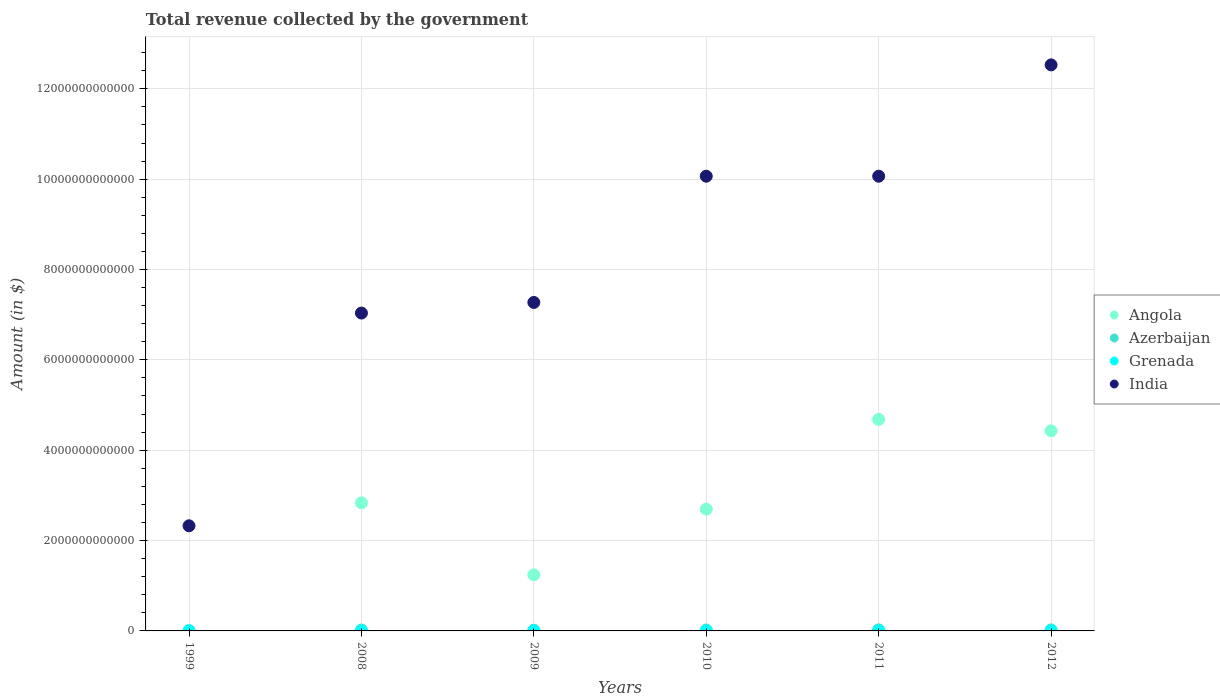Is the number of dotlines equal to the number of legend labels?
Provide a succinct answer. Yes. What is the total revenue collected by the government in Grenada in 2010?
Provide a short and direct response. 4.15e+08. Across all years, what is the maximum total revenue collected by the government in India?
Provide a short and direct response. 1.25e+13. Across all years, what is the minimum total revenue collected by the government in Angola?
Give a very brief answer. 7.21e+09. In which year was the total revenue collected by the government in Angola minimum?
Keep it short and to the point. 1999. What is the total total revenue collected by the government in India in the graph?
Your answer should be very brief. 4.93e+13. What is the difference between the total revenue collected by the government in Angola in 1999 and that in 2009?
Your response must be concise. -1.23e+12. What is the difference between the total revenue collected by the government in Grenada in 2011 and the total revenue collected by the government in India in 2010?
Offer a very short reply. -1.01e+13. What is the average total revenue collected by the government in Grenada per year?
Ensure brevity in your answer.  4.00e+08. In the year 2011, what is the difference between the total revenue collected by the government in Azerbaijan and total revenue collected by the government in Angola?
Your response must be concise. -4.66e+12. What is the ratio of the total revenue collected by the government in India in 2009 to that in 2011?
Your response must be concise. 0.72. Is the total revenue collected by the government in Angola in 1999 less than that in 2010?
Provide a succinct answer. Yes. Is the difference between the total revenue collected by the government in Azerbaijan in 2008 and 2010 greater than the difference between the total revenue collected by the government in Angola in 2008 and 2010?
Your response must be concise. No. What is the difference between the highest and the second highest total revenue collected by the government in Azerbaijan?
Offer a terse response. 1.09e+09. What is the difference between the highest and the lowest total revenue collected by the government in Azerbaijan?
Your answer should be very brief. 2.30e+1. In how many years, is the total revenue collected by the government in India greater than the average total revenue collected by the government in India taken over all years?
Provide a short and direct response. 3. Is the sum of the total revenue collected by the government in Azerbaijan in 1999 and 2012 greater than the maximum total revenue collected by the government in India across all years?
Offer a very short reply. No. Is it the case that in every year, the sum of the total revenue collected by the government in Grenada and total revenue collected by the government in Angola  is greater than the sum of total revenue collected by the government in India and total revenue collected by the government in Azerbaijan?
Your answer should be very brief. No. How many dotlines are there?
Make the answer very short. 4. How many years are there in the graph?
Offer a terse response. 6. What is the difference between two consecutive major ticks on the Y-axis?
Ensure brevity in your answer.  2.00e+12. Does the graph contain grids?
Provide a short and direct response. Yes. Where does the legend appear in the graph?
Your answer should be very brief. Center right. What is the title of the graph?
Your answer should be very brief. Total revenue collected by the government. What is the label or title of the Y-axis?
Make the answer very short. Amount (in $). What is the Amount (in $) in Angola in 1999?
Offer a terse response. 7.21e+09. What is the Amount (in $) in Azerbaijan in 1999?
Offer a terse response. 6.63e+08. What is the Amount (in $) of Grenada in 1999?
Make the answer very short. 2.67e+08. What is the Amount (in $) in India in 1999?
Your answer should be compact. 2.33e+12. What is the Amount (in $) of Angola in 2008?
Keep it short and to the point. 2.83e+12. What is the Amount (in $) in Azerbaijan in 2008?
Give a very brief answer. 1.98e+1. What is the Amount (in $) in Grenada in 2008?
Your answer should be very brief. 4.65e+08. What is the Amount (in $) of India in 2008?
Make the answer very short. 7.04e+12. What is the Amount (in $) of Angola in 2009?
Provide a succinct answer. 1.24e+12. What is the Amount (in $) of Azerbaijan in 2009?
Your response must be concise. 1.46e+1. What is the Amount (in $) in Grenada in 2009?
Give a very brief answer. 4.02e+08. What is the Amount (in $) of India in 2009?
Provide a succinct answer. 7.27e+12. What is the Amount (in $) in Angola in 2010?
Offer a very short reply. 2.70e+12. What is the Amount (in $) in Azerbaijan in 2010?
Keep it short and to the point. 1.99e+1. What is the Amount (in $) of Grenada in 2010?
Your answer should be compact. 4.15e+08. What is the Amount (in $) in India in 2010?
Offer a terse response. 1.01e+13. What is the Amount (in $) in Angola in 2011?
Your response must be concise. 4.68e+12. What is the Amount (in $) in Azerbaijan in 2011?
Keep it short and to the point. 2.37e+1. What is the Amount (in $) of Grenada in 2011?
Ensure brevity in your answer.  4.26e+08. What is the Amount (in $) of India in 2011?
Provide a short and direct response. 1.01e+13. What is the Amount (in $) in Angola in 2012?
Make the answer very short. 4.43e+12. What is the Amount (in $) of Azerbaijan in 2012?
Your response must be concise. 2.26e+1. What is the Amount (in $) of Grenada in 2012?
Provide a succinct answer. 4.25e+08. What is the Amount (in $) of India in 2012?
Keep it short and to the point. 1.25e+13. Across all years, what is the maximum Amount (in $) of Angola?
Your response must be concise. 4.68e+12. Across all years, what is the maximum Amount (in $) in Azerbaijan?
Ensure brevity in your answer.  2.37e+1. Across all years, what is the maximum Amount (in $) of Grenada?
Your response must be concise. 4.65e+08. Across all years, what is the maximum Amount (in $) of India?
Offer a terse response. 1.25e+13. Across all years, what is the minimum Amount (in $) in Angola?
Your answer should be very brief. 7.21e+09. Across all years, what is the minimum Amount (in $) of Azerbaijan?
Your answer should be compact. 6.63e+08. Across all years, what is the minimum Amount (in $) in Grenada?
Your response must be concise. 2.67e+08. Across all years, what is the minimum Amount (in $) in India?
Make the answer very short. 2.33e+12. What is the total Amount (in $) of Angola in the graph?
Give a very brief answer. 1.59e+13. What is the total Amount (in $) in Azerbaijan in the graph?
Your answer should be compact. 1.01e+11. What is the total Amount (in $) of Grenada in the graph?
Give a very brief answer. 2.40e+09. What is the total Amount (in $) of India in the graph?
Give a very brief answer. 4.93e+13. What is the difference between the Amount (in $) of Angola in 1999 and that in 2008?
Your answer should be very brief. -2.83e+12. What is the difference between the Amount (in $) in Azerbaijan in 1999 and that in 2008?
Provide a succinct answer. -1.91e+1. What is the difference between the Amount (in $) of Grenada in 1999 and that in 2008?
Make the answer very short. -1.97e+08. What is the difference between the Amount (in $) in India in 1999 and that in 2008?
Your answer should be compact. -4.71e+12. What is the difference between the Amount (in $) of Angola in 1999 and that in 2009?
Keep it short and to the point. -1.23e+12. What is the difference between the Amount (in $) in Azerbaijan in 1999 and that in 2009?
Give a very brief answer. -1.39e+1. What is the difference between the Amount (in $) in Grenada in 1999 and that in 2009?
Offer a very short reply. -1.34e+08. What is the difference between the Amount (in $) in India in 1999 and that in 2009?
Make the answer very short. -4.94e+12. What is the difference between the Amount (in $) in Angola in 1999 and that in 2010?
Your answer should be very brief. -2.69e+12. What is the difference between the Amount (in $) in Azerbaijan in 1999 and that in 2010?
Offer a terse response. -1.92e+1. What is the difference between the Amount (in $) in Grenada in 1999 and that in 2010?
Offer a very short reply. -1.48e+08. What is the difference between the Amount (in $) of India in 1999 and that in 2010?
Provide a succinct answer. -7.74e+12. What is the difference between the Amount (in $) in Angola in 1999 and that in 2011?
Offer a terse response. -4.68e+12. What is the difference between the Amount (in $) in Azerbaijan in 1999 and that in 2011?
Offer a terse response. -2.30e+1. What is the difference between the Amount (in $) of Grenada in 1999 and that in 2011?
Provide a short and direct response. -1.58e+08. What is the difference between the Amount (in $) of India in 1999 and that in 2011?
Offer a very short reply. -7.74e+12. What is the difference between the Amount (in $) of Angola in 1999 and that in 2012?
Ensure brevity in your answer.  -4.42e+12. What is the difference between the Amount (in $) of Azerbaijan in 1999 and that in 2012?
Give a very brief answer. -2.19e+1. What is the difference between the Amount (in $) in Grenada in 1999 and that in 2012?
Your response must be concise. -1.58e+08. What is the difference between the Amount (in $) in India in 1999 and that in 2012?
Your answer should be compact. -1.02e+13. What is the difference between the Amount (in $) of Angola in 2008 and that in 2009?
Offer a terse response. 1.59e+12. What is the difference between the Amount (in $) of Azerbaijan in 2008 and that in 2009?
Provide a short and direct response. 5.23e+09. What is the difference between the Amount (in $) in Grenada in 2008 and that in 2009?
Your answer should be compact. 6.28e+07. What is the difference between the Amount (in $) in India in 2008 and that in 2009?
Keep it short and to the point. -2.35e+11. What is the difference between the Amount (in $) of Angola in 2008 and that in 2010?
Offer a terse response. 1.39e+11. What is the difference between the Amount (in $) in Azerbaijan in 2008 and that in 2010?
Your answer should be very brief. -9.75e+07. What is the difference between the Amount (in $) of Grenada in 2008 and that in 2010?
Give a very brief answer. 4.96e+07. What is the difference between the Amount (in $) in India in 2008 and that in 2010?
Your answer should be very brief. -3.03e+12. What is the difference between the Amount (in $) in Angola in 2008 and that in 2011?
Your answer should be compact. -1.85e+12. What is the difference between the Amount (in $) of Azerbaijan in 2008 and that in 2011?
Provide a succinct answer. -3.90e+09. What is the difference between the Amount (in $) in Grenada in 2008 and that in 2011?
Your answer should be compact. 3.89e+07. What is the difference between the Amount (in $) in India in 2008 and that in 2011?
Provide a short and direct response. -3.03e+12. What is the difference between the Amount (in $) of Angola in 2008 and that in 2012?
Ensure brevity in your answer.  -1.59e+12. What is the difference between the Amount (in $) of Azerbaijan in 2008 and that in 2012?
Offer a very short reply. -2.81e+09. What is the difference between the Amount (in $) in Grenada in 2008 and that in 2012?
Provide a succinct answer. 3.93e+07. What is the difference between the Amount (in $) in India in 2008 and that in 2012?
Provide a short and direct response. -5.49e+12. What is the difference between the Amount (in $) of Angola in 2009 and that in 2010?
Offer a terse response. -1.45e+12. What is the difference between the Amount (in $) of Azerbaijan in 2009 and that in 2010?
Your answer should be very brief. -5.33e+09. What is the difference between the Amount (in $) of Grenada in 2009 and that in 2010?
Provide a succinct answer. -1.32e+07. What is the difference between the Amount (in $) of India in 2009 and that in 2010?
Ensure brevity in your answer.  -2.79e+12. What is the difference between the Amount (in $) of Angola in 2009 and that in 2011?
Give a very brief answer. -3.44e+12. What is the difference between the Amount (in $) of Azerbaijan in 2009 and that in 2011?
Your answer should be compact. -9.13e+09. What is the difference between the Amount (in $) in Grenada in 2009 and that in 2011?
Make the answer very short. -2.39e+07. What is the difference between the Amount (in $) of India in 2009 and that in 2011?
Give a very brief answer. -2.79e+12. What is the difference between the Amount (in $) in Angola in 2009 and that in 2012?
Make the answer very short. -3.19e+12. What is the difference between the Amount (in $) of Azerbaijan in 2009 and that in 2012?
Provide a short and direct response. -8.04e+09. What is the difference between the Amount (in $) of Grenada in 2009 and that in 2012?
Offer a very short reply. -2.35e+07. What is the difference between the Amount (in $) of India in 2009 and that in 2012?
Keep it short and to the point. -5.26e+12. What is the difference between the Amount (in $) of Angola in 2010 and that in 2011?
Ensure brevity in your answer.  -1.99e+12. What is the difference between the Amount (in $) in Azerbaijan in 2010 and that in 2011?
Offer a terse response. -3.80e+09. What is the difference between the Amount (in $) in Grenada in 2010 and that in 2011?
Ensure brevity in your answer.  -1.07e+07. What is the difference between the Amount (in $) in India in 2010 and that in 2011?
Your response must be concise. 0. What is the difference between the Amount (in $) of Angola in 2010 and that in 2012?
Give a very brief answer. -1.73e+12. What is the difference between the Amount (in $) of Azerbaijan in 2010 and that in 2012?
Your answer should be compact. -2.71e+09. What is the difference between the Amount (in $) in Grenada in 2010 and that in 2012?
Make the answer very short. -1.03e+07. What is the difference between the Amount (in $) of India in 2010 and that in 2012?
Ensure brevity in your answer.  -2.46e+12. What is the difference between the Amount (in $) of Angola in 2011 and that in 2012?
Provide a succinct answer. 2.54e+11. What is the difference between the Amount (in $) of Azerbaijan in 2011 and that in 2012?
Provide a succinct answer. 1.09e+09. What is the difference between the Amount (in $) of Grenada in 2011 and that in 2012?
Ensure brevity in your answer.  4.00e+05. What is the difference between the Amount (in $) of India in 2011 and that in 2012?
Offer a terse response. -2.46e+12. What is the difference between the Amount (in $) of Angola in 1999 and the Amount (in $) of Azerbaijan in 2008?
Offer a terse response. -1.26e+1. What is the difference between the Amount (in $) in Angola in 1999 and the Amount (in $) in Grenada in 2008?
Provide a short and direct response. 6.75e+09. What is the difference between the Amount (in $) in Angola in 1999 and the Amount (in $) in India in 2008?
Give a very brief answer. -7.03e+12. What is the difference between the Amount (in $) in Azerbaijan in 1999 and the Amount (in $) in Grenada in 2008?
Ensure brevity in your answer.  1.99e+08. What is the difference between the Amount (in $) of Azerbaijan in 1999 and the Amount (in $) of India in 2008?
Offer a very short reply. -7.04e+12. What is the difference between the Amount (in $) in Grenada in 1999 and the Amount (in $) in India in 2008?
Offer a very short reply. -7.04e+12. What is the difference between the Amount (in $) of Angola in 1999 and the Amount (in $) of Azerbaijan in 2009?
Make the answer very short. -7.34e+09. What is the difference between the Amount (in $) in Angola in 1999 and the Amount (in $) in Grenada in 2009?
Your answer should be compact. 6.81e+09. What is the difference between the Amount (in $) in Angola in 1999 and the Amount (in $) in India in 2009?
Keep it short and to the point. -7.26e+12. What is the difference between the Amount (in $) in Azerbaijan in 1999 and the Amount (in $) in Grenada in 2009?
Your response must be concise. 2.62e+08. What is the difference between the Amount (in $) in Azerbaijan in 1999 and the Amount (in $) in India in 2009?
Offer a terse response. -7.27e+12. What is the difference between the Amount (in $) in Grenada in 1999 and the Amount (in $) in India in 2009?
Your answer should be compact. -7.27e+12. What is the difference between the Amount (in $) of Angola in 1999 and the Amount (in $) of Azerbaijan in 2010?
Provide a short and direct response. -1.27e+1. What is the difference between the Amount (in $) in Angola in 1999 and the Amount (in $) in Grenada in 2010?
Offer a very short reply. 6.80e+09. What is the difference between the Amount (in $) of Angola in 1999 and the Amount (in $) of India in 2010?
Offer a terse response. -1.01e+13. What is the difference between the Amount (in $) of Azerbaijan in 1999 and the Amount (in $) of Grenada in 2010?
Offer a terse response. 2.48e+08. What is the difference between the Amount (in $) of Azerbaijan in 1999 and the Amount (in $) of India in 2010?
Your answer should be compact. -1.01e+13. What is the difference between the Amount (in $) in Grenada in 1999 and the Amount (in $) in India in 2010?
Your response must be concise. -1.01e+13. What is the difference between the Amount (in $) in Angola in 1999 and the Amount (in $) in Azerbaijan in 2011?
Give a very brief answer. -1.65e+1. What is the difference between the Amount (in $) of Angola in 1999 and the Amount (in $) of Grenada in 2011?
Offer a terse response. 6.79e+09. What is the difference between the Amount (in $) of Angola in 1999 and the Amount (in $) of India in 2011?
Your answer should be very brief. -1.01e+13. What is the difference between the Amount (in $) of Azerbaijan in 1999 and the Amount (in $) of Grenada in 2011?
Provide a short and direct response. 2.38e+08. What is the difference between the Amount (in $) in Azerbaijan in 1999 and the Amount (in $) in India in 2011?
Provide a succinct answer. -1.01e+13. What is the difference between the Amount (in $) of Grenada in 1999 and the Amount (in $) of India in 2011?
Provide a succinct answer. -1.01e+13. What is the difference between the Amount (in $) of Angola in 1999 and the Amount (in $) of Azerbaijan in 2012?
Your answer should be very brief. -1.54e+1. What is the difference between the Amount (in $) of Angola in 1999 and the Amount (in $) of Grenada in 2012?
Give a very brief answer. 6.79e+09. What is the difference between the Amount (in $) in Angola in 1999 and the Amount (in $) in India in 2012?
Your answer should be very brief. -1.25e+13. What is the difference between the Amount (in $) of Azerbaijan in 1999 and the Amount (in $) of Grenada in 2012?
Ensure brevity in your answer.  2.38e+08. What is the difference between the Amount (in $) in Azerbaijan in 1999 and the Amount (in $) in India in 2012?
Keep it short and to the point. -1.25e+13. What is the difference between the Amount (in $) in Grenada in 1999 and the Amount (in $) in India in 2012?
Your response must be concise. -1.25e+13. What is the difference between the Amount (in $) in Angola in 2008 and the Amount (in $) in Azerbaijan in 2009?
Your answer should be compact. 2.82e+12. What is the difference between the Amount (in $) of Angola in 2008 and the Amount (in $) of Grenada in 2009?
Give a very brief answer. 2.83e+12. What is the difference between the Amount (in $) of Angola in 2008 and the Amount (in $) of India in 2009?
Keep it short and to the point. -4.44e+12. What is the difference between the Amount (in $) in Azerbaijan in 2008 and the Amount (in $) in Grenada in 2009?
Your response must be concise. 1.94e+1. What is the difference between the Amount (in $) in Azerbaijan in 2008 and the Amount (in $) in India in 2009?
Your answer should be very brief. -7.25e+12. What is the difference between the Amount (in $) in Grenada in 2008 and the Amount (in $) in India in 2009?
Make the answer very short. -7.27e+12. What is the difference between the Amount (in $) in Angola in 2008 and the Amount (in $) in Azerbaijan in 2010?
Offer a terse response. 2.81e+12. What is the difference between the Amount (in $) in Angola in 2008 and the Amount (in $) in Grenada in 2010?
Ensure brevity in your answer.  2.83e+12. What is the difference between the Amount (in $) of Angola in 2008 and the Amount (in $) of India in 2010?
Give a very brief answer. -7.23e+12. What is the difference between the Amount (in $) of Azerbaijan in 2008 and the Amount (in $) of Grenada in 2010?
Provide a succinct answer. 1.94e+1. What is the difference between the Amount (in $) of Azerbaijan in 2008 and the Amount (in $) of India in 2010?
Offer a terse response. -1.00e+13. What is the difference between the Amount (in $) in Grenada in 2008 and the Amount (in $) in India in 2010?
Your response must be concise. -1.01e+13. What is the difference between the Amount (in $) in Angola in 2008 and the Amount (in $) in Azerbaijan in 2011?
Your answer should be compact. 2.81e+12. What is the difference between the Amount (in $) in Angola in 2008 and the Amount (in $) in Grenada in 2011?
Provide a succinct answer. 2.83e+12. What is the difference between the Amount (in $) of Angola in 2008 and the Amount (in $) of India in 2011?
Offer a terse response. -7.23e+12. What is the difference between the Amount (in $) of Azerbaijan in 2008 and the Amount (in $) of Grenada in 2011?
Make the answer very short. 1.94e+1. What is the difference between the Amount (in $) in Azerbaijan in 2008 and the Amount (in $) in India in 2011?
Ensure brevity in your answer.  -1.00e+13. What is the difference between the Amount (in $) in Grenada in 2008 and the Amount (in $) in India in 2011?
Make the answer very short. -1.01e+13. What is the difference between the Amount (in $) of Angola in 2008 and the Amount (in $) of Azerbaijan in 2012?
Keep it short and to the point. 2.81e+12. What is the difference between the Amount (in $) of Angola in 2008 and the Amount (in $) of Grenada in 2012?
Your response must be concise. 2.83e+12. What is the difference between the Amount (in $) of Angola in 2008 and the Amount (in $) of India in 2012?
Ensure brevity in your answer.  -9.69e+12. What is the difference between the Amount (in $) of Azerbaijan in 2008 and the Amount (in $) of Grenada in 2012?
Make the answer very short. 1.94e+1. What is the difference between the Amount (in $) of Azerbaijan in 2008 and the Amount (in $) of India in 2012?
Offer a terse response. -1.25e+13. What is the difference between the Amount (in $) of Grenada in 2008 and the Amount (in $) of India in 2012?
Ensure brevity in your answer.  -1.25e+13. What is the difference between the Amount (in $) in Angola in 2009 and the Amount (in $) in Azerbaijan in 2010?
Your response must be concise. 1.22e+12. What is the difference between the Amount (in $) of Angola in 2009 and the Amount (in $) of Grenada in 2010?
Provide a short and direct response. 1.24e+12. What is the difference between the Amount (in $) of Angola in 2009 and the Amount (in $) of India in 2010?
Make the answer very short. -8.82e+12. What is the difference between the Amount (in $) in Azerbaijan in 2009 and the Amount (in $) in Grenada in 2010?
Your answer should be very brief. 1.41e+1. What is the difference between the Amount (in $) of Azerbaijan in 2009 and the Amount (in $) of India in 2010?
Provide a succinct answer. -1.01e+13. What is the difference between the Amount (in $) in Grenada in 2009 and the Amount (in $) in India in 2010?
Provide a short and direct response. -1.01e+13. What is the difference between the Amount (in $) of Angola in 2009 and the Amount (in $) of Azerbaijan in 2011?
Offer a terse response. 1.22e+12. What is the difference between the Amount (in $) in Angola in 2009 and the Amount (in $) in Grenada in 2011?
Offer a terse response. 1.24e+12. What is the difference between the Amount (in $) in Angola in 2009 and the Amount (in $) in India in 2011?
Ensure brevity in your answer.  -8.82e+12. What is the difference between the Amount (in $) of Azerbaijan in 2009 and the Amount (in $) of Grenada in 2011?
Ensure brevity in your answer.  1.41e+1. What is the difference between the Amount (in $) in Azerbaijan in 2009 and the Amount (in $) in India in 2011?
Provide a short and direct response. -1.01e+13. What is the difference between the Amount (in $) in Grenada in 2009 and the Amount (in $) in India in 2011?
Keep it short and to the point. -1.01e+13. What is the difference between the Amount (in $) in Angola in 2009 and the Amount (in $) in Azerbaijan in 2012?
Make the answer very short. 1.22e+12. What is the difference between the Amount (in $) in Angola in 2009 and the Amount (in $) in Grenada in 2012?
Offer a very short reply. 1.24e+12. What is the difference between the Amount (in $) of Angola in 2009 and the Amount (in $) of India in 2012?
Give a very brief answer. -1.13e+13. What is the difference between the Amount (in $) in Azerbaijan in 2009 and the Amount (in $) in Grenada in 2012?
Provide a succinct answer. 1.41e+1. What is the difference between the Amount (in $) in Azerbaijan in 2009 and the Amount (in $) in India in 2012?
Make the answer very short. -1.25e+13. What is the difference between the Amount (in $) of Grenada in 2009 and the Amount (in $) of India in 2012?
Your answer should be compact. -1.25e+13. What is the difference between the Amount (in $) in Angola in 2010 and the Amount (in $) in Azerbaijan in 2011?
Provide a succinct answer. 2.67e+12. What is the difference between the Amount (in $) of Angola in 2010 and the Amount (in $) of Grenada in 2011?
Provide a short and direct response. 2.69e+12. What is the difference between the Amount (in $) in Angola in 2010 and the Amount (in $) in India in 2011?
Provide a short and direct response. -7.37e+12. What is the difference between the Amount (in $) in Azerbaijan in 2010 and the Amount (in $) in Grenada in 2011?
Make the answer very short. 1.95e+1. What is the difference between the Amount (in $) of Azerbaijan in 2010 and the Amount (in $) of India in 2011?
Keep it short and to the point. -1.00e+13. What is the difference between the Amount (in $) of Grenada in 2010 and the Amount (in $) of India in 2011?
Ensure brevity in your answer.  -1.01e+13. What is the difference between the Amount (in $) of Angola in 2010 and the Amount (in $) of Azerbaijan in 2012?
Offer a very short reply. 2.67e+12. What is the difference between the Amount (in $) in Angola in 2010 and the Amount (in $) in Grenada in 2012?
Give a very brief answer. 2.69e+12. What is the difference between the Amount (in $) in Angola in 2010 and the Amount (in $) in India in 2012?
Offer a very short reply. -9.83e+12. What is the difference between the Amount (in $) of Azerbaijan in 2010 and the Amount (in $) of Grenada in 2012?
Your answer should be compact. 1.95e+1. What is the difference between the Amount (in $) of Azerbaijan in 2010 and the Amount (in $) of India in 2012?
Provide a short and direct response. -1.25e+13. What is the difference between the Amount (in $) of Grenada in 2010 and the Amount (in $) of India in 2012?
Ensure brevity in your answer.  -1.25e+13. What is the difference between the Amount (in $) in Angola in 2011 and the Amount (in $) in Azerbaijan in 2012?
Provide a short and direct response. 4.66e+12. What is the difference between the Amount (in $) in Angola in 2011 and the Amount (in $) in Grenada in 2012?
Your answer should be very brief. 4.68e+12. What is the difference between the Amount (in $) in Angola in 2011 and the Amount (in $) in India in 2012?
Provide a short and direct response. -7.85e+12. What is the difference between the Amount (in $) of Azerbaijan in 2011 and the Amount (in $) of Grenada in 2012?
Make the answer very short. 2.33e+1. What is the difference between the Amount (in $) of Azerbaijan in 2011 and the Amount (in $) of India in 2012?
Offer a very short reply. -1.25e+13. What is the difference between the Amount (in $) of Grenada in 2011 and the Amount (in $) of India in 2012?
Your response must be concise. -1.25e+13. What is the average Amount (in $) in Angola per year?
Your response must be concise. 2.65e+12. What is the average Amount (in $) of Azerbaijan per year?
Your answer should be very brief. 1.69e+1. What is the average Amount (in $) in Grenada per year?
Make the answer very short. 4.00e+08. What is the average Amount (in $) of India per year?
Provide a succinct answer. 8.22e+12. In the year 1999, what is the difference between the Amount (in $) in Angola and Amount (in $) in Azerbaijan?
Make the answer very short. 6.55e+09. In the year 1999, what is the difference between the Amount (in $) in Angola and Amount (in $) in Grenada?
Give a very brief answer. 6.95e+09. In the year 1999, what is the difference between the Amount (in $) of Angola and Amount (in $) of India?
Offer a very short reply. -2.32e+12. In the year 1999, what is the difference between the Amount (in $) in Azerbaijan and Amount (in $) in Grenada?
Offer a very short reply. 3.96e+08. In the year 1999, what is the difference between the Amount (in $) in Azerbaijan and Amount (in $) in India?
Your response must be concise. -2.33e+12. In the year 1999, what is the difference between the Amount (in $) of Grenada and Amount (in $) of India?
Provide a succinct answer. -2.33e+12. In the year 2008, what is the difference between the Amount (in $) of Angola and Amount (in $) of Azerbaijan?
Your answer should be compact. 2.81e+12. In the year 2008, what is the difference between the Amount (in $) in Angola and Amount (in $) in Grenada?
Give a very brief answer. 2.83e+12. In the year 2008, what is the difference between the Amount (in $) of Angola and Amount (in $) of India?
Keep it short and to the point. -4.20e+12. In the year 2008, what is the difference between the Amount (in $) in Azerbaijan and Amount (in $) in Grenada?
Give a very brief answer. 1.93e+1. In the year 2008, what is the difference between the Amount (in $) in Azerbaijan and Amount (in $) in India?
Provide a short and direct response. -7.02e+12. In the year 2008, what is the difference between the Amount (in $) of Grenada and Amount (in $) of India?
Ensure brevity in your answer.  -7.04e+12. In the year 2009, what is the difference between the Amount (in $) in Angola and Amount (in $) in Azerbaijan?
Offer a terse response. 1.23e+12. In the year 2009, what is the difference between the Amount (in $) of Angola and Amount (in $) of Grenada?
Offer a very short reply. 1.24e+12. In the year 2009, what is the difference between the Amount (in $) of Angola and Amount (in $) of India?
Your answer should be very brief. -6.03e+12. In the year 2009, what is the difference between the Amount (in $) in Azerbaijan and Amount (in $) in Grenada?
Provide a succinct answer. 1.42e+1. In the year 2009, what is the difference between the Amount (in $) of Azerbaijan and Amount (in $) of India?
Keep it short and to the point. -7.26e+12. In the year 2009, what is the difference between the Amount (in $) in Grenada and Amount (in $) in India?
Offer a very short reply. -7.27e+12. In the year 2010, what is the difference between the Amount (in $) in Angola and Amount (in $) in Azerbaijan?
Your answer should be very brief. 2.68e+12. In the year 2010, what is the difference between the Amount (in $) of Angola and Amount (in $) of Grenada?
Keep it short and to the point. 2.69e+12. In the year 2010, what is the difference between the Amount (in $) of Angola and Amount (in $) of India?
Offer a terse response. -7.37e+12. In the year 2010, what is the difference between the Amount (in $) of Azerbaijan and Amount (in $) of Grenada?
Offer a very short reply. 1.95e+1. In the year 2010, what is the difference between the Amount (in $) of Azerbaijan and Amount (in $) of India?
Give a very brief answer. -1.00e+13. In the year 2010, what is the difference between the Amount (in $) of Grenada and Amount (in $) of India?
Ensure brevity in your answer.  -1.01e+13. In the year 2011, what is the difference between the Amount (in $) in Angola and Amount (in $) in Azerbaijan?
Provide a short and direct response. 4.66e+12. In the year 2011, what is the difference between the Amount (in $) of Angola and Amount (in $) of Grenada?
Provide a short and direct response. 4.68e+12. In the year 2011, what is the difference between the Amount (in $) in Angola and Amount (in $) in India?
Offer a terse response. -5.38e+12. In the year 2011, what is the difference between the Amount (in $) of Azerbaijan and Amount (in $) of Grenada?
Offer a terse response. 2.33e+1. In the year 2011, what is the difference between the Amount (in $) in Azerbaijan and Amount (in $) in India?
Offer a terse response. -1.00e+13. In the year 2011, what is the difference between the Amount (in $) in Grenada and Amount (in $) in India?
Give a very brief answer. -1.01e+13. In the year 2012, what is the difference between the Amount (in $) of Angola and Amount (in $) of Azerbaijan?
Your answer should be very brief. 4.41e+12. In the year 2012, what is the difference between the Amount (in $) in Angola and Amount (in $) in Grenada?
Keep it short and to the point. 4.43e+12. In the year 2012, what is the difference between the Amount (in $) in Angola and Amount (in $) in India?
Make the answer very short. -8.10e+12. In the year 2012, what is the difference between the Amount (in $) of Azerbaijan and Amount (in $) of Grenada?
Keep it short and to the point. 2.22e+1. In the year 2012, what is the difference between the Amount (in $) in Azerbaijan and Amount (in $) in India?
Offer a terse response. -1.25e+13. In the year 2012, what is the difference between the Amount (in $) in Grenada and Amount (in $) in India?
Give a very brief answer. -1.25e+13. What is the ratio of the Amount (in $) in Angola in 1999 to that in 2008?
Your answer should be very brief. 0. What is the ratio of the Amount (in $) of Azerbaijan in 1999 to that in 2008?
Provide a short and direct response. 0.03. What is the ratio of the Amount (in $) of Grenada in 1999 to that in 2008?
Your answer should be compact. 0.58. What is the ratio of the Amount (in $) of India in 1999 to that in 2008?
Offer a terse response. 0.33. What is the ratio of the Amount (in $) in Angola in 1999 to that in 2009?
Provide a succinct answer. 0.01. What is the ratio of the Amount (in $) in Azerbaijan in 1999 to that in 2009?
Make the answer very short. 0.05. What is the ratio of the Amount (in $) of Grenada in 1999 to that in 2009?
Provide a short and direct response. 0.67. What is the ratio of the Amount (in $) of India in 1999 to that in 2009?
Give a very brief answer. 0.32. What is the ratio of the Amount (in $) of Angola in 1999 to that in 2010?
Offer a terse response. 0. What is the ratio of the Amount (in $) in Azerbaijan in 1999 to that in 2010?
Offer a terse response. 0.03. What is the ratio of the Amount (in $) of Grenada in 1999 to that in 2010?
Offer a terse response. 0.64. What is the ratio of the Amount (in $) of India in 1999 to that in 2010?
Keep it short and to the point. 0.23. What is the ratio of the Amount (in $) of Angola in 1999 to that in 2011?
Your answer should be compact. 0. What is the ratio of the Amount (in $) of Azerbaijan in 1999 to that in 2011?
Provide a succinct answer. 0.03. What is the ratio of the Amount (in $) of Grenada in 1999 to that in 2011?
Your answer should be very brief. 0.63. What is the ratio of the Amount (in $) of India in 1999 to that in 2011?
Provide a short and direct response. 0.23. What is the ratio of the Amount (in $) in Angola in 1999 to that in 2012?
Offer a very short reply. 0. What is the ratio of the Amount (in $) in Azerbaijan in 1999 to that in 2012?
Give a very brief answer. 0.03. What is the ratio of the Amount (in $) of Grenada in 1999 to that in 2012?
Give a very brief answer. 0.63. What is the ratio of the Amount (in $) of India in 1999 to that in 2012?
Make the answer very short. 0.19. What is the ratio of the Amount (in $) of Angola in 2008 to that in 2009?
Ensure brevity in your answer.  2.28. What is the ratio of the Amount (in $) in Azerbaijan in 2008 to that in 2009?
Provide a succinct answer. 1.36. What is the ratio of the Amount (in $) in Grenada in 2008 to that in 2009?
Make the answer very short. 1.16. What is the ratio of the Amount (in $) in India in 2008 to that in 2009?
Keep it short and to the point. 0.97. What is the ratio of the Amount (in $) of Angola in 2008 to that in 2010?
Make the answer very short. 1.05. What is the ratio of the Amount (in $) of Azerbaijan in 2008 to that in 2010?
Provide a succinct answer. 1. What is the ratio of the Amount (in $) in Grenada in 2008 to that in 2010?
Your response must be concise. 1.12. What is the ratio of the Amount (in $) of India in 2008 to that in 2010?
Provide a succinct answer. 0.7. What is the ratio of the Amount (in $) of Angola in 2008 to that in 2011?
Provide a succinct answer. 0.61. What is the ratio of the Amount (in $) of Azerbaijan in 2008 to that in 2011?
Ensure brevity in your answer.  0.84. What is the ratio of the Amount (in $) in Grenada in 2008 to that in 2011?
Give a very brief answer. 1.09. What is the ratio of the Amount (in $) of India in 2008 to that in 2011?
Your answer should be compact. 0.7. What is the ratio of the Amount (in $) in Angola in 2008 to that in 2012?
Offer a terse response. 0.64. What is the ratio of the Amount (in $) in Azerbaijan in 2008 to that in 2012?
Your response must be concise. 0.88. What is the ratio of the Amount (in $) in Grenada in 2008 to that in 2012?
Provide a short and direct response. 1.09. What is the ratio of the Amount (in $) in India in 2008 to that in 2012?
Make the answer very short. 0.56. What is the ratio of the Amount (in $) in Angola in 2009 to that in 2010?
Offer a very short reply. 0.46. What is the ratio of the Amount (in $) of Azerbaijan in 2009 to that in 2010?
Your answer should be very brief. 0.73. What is the ratio of the Amount (in $) of Grenada in 2009 to that in 2010?
Provide a succinct answer. 0.97. What is the ratio of the Amount (in $) of India in 2009 to that in 2010?
Your response must be concise. 0.72. What is the ratio of the Amount (in $) of Angola in 2009 to that in 2011?
Provide a short and direct response. 0.27. What is the ratio of the Amount (in $) of Azerbaijan in 2009 to that in 2011?
Make the answer very short. 0.61. What is the ratio of the Amount (in $) of Grenada in 2009 to that in 2011?
Your answer should be very brief. 0.94. What is the ratio of the Amount (in $) in India in 2009 to that in 2011?
Offer a very short reply. 0.72. What is the ratio of the Amount (in $) of Angola in 2009 to that in 2012?
Provide a succinct answer. 0.28. What is the ratio of the Amount (in $) of Azerbaijan in 2009 to that in 2012?
Give a very brief answer. 0.64. What is the ratio of the Amount (in $) of Grenada in 2009 to that in 2012?
Give a very brief answer. 0.94. What is the ratio of the Amount (in $) in India in 2009 to that in 2012?
Your answer should be very brief. 0.58. What is the ratio of the Amount (in $) of Angola in 2010 to that in 2011?
Provide a short and direct response. 0.58. What is the ratio of the Amount (in $) of Azerbaijan in 2010 to that in 2011?
Your response must be concise. 0.84. What is the ratio of the Amount (in $) in Grenada in 2010 to that in 2011?
Give a very brief answer. 0.97. What is the ratio of the Amount (in $) in Angola in 2010 to that in 2012?
Ensure brevity in your answer.  0.61. What is the ratio of the Amount (in $) of Azerbaijan in 2010 to that in 2012?
Ensure brevity in your answer.  0.88. What is the ratio of the Amount (in $) of Grenada in 2010 to that in 2012?
Provide a succinct answer. 0.98. What is the ratio of the Amount (in $) in India in 2010 to that in 2012?
Ensure brevity in your answer.  0.8. What is the ratio of the Amount (in $) of Angola in 2011 to that in 2012?
Provide a short and direct response. 1.06. What is the ratio of the Amount (in $) in Azerbaijan in 2011 to that in 2012?
Offer a very short reply. 1.05. What is the ratio of the Amount (in $) in India in 2011 to that in 2012?
Make the answer very short. 0.8. What is the difference between the highest and the second highest Amount (in $) in Angola?
Ensure brevity in your answer.  2.54e+11. What is the difference between the highest and the second highest Amount (in $) of Azerbaijan?
Keep it short and to the point. 1.09e+09. What is the difference between the highest and the second highest Amount (in $) in Grenada?
Your answer should be compact. 3.89e+07. What is the difference between the highest and the second highest Amount (in $) in India?
Offer a terse response. 2.46e+12. What is the difference between the highest and the lowest Amount (in $) of Angola?
Make the answer very short. 4.68e+12. What is the difference between the highest and the lowest Amount (in $) of Azerbaijan?
Make the answer very short. 2.30e+1. What is the difference between the highest and the lowest Amount (in $) in Grenada?
Ensure brevity in your answer.  1.97e+08. What is the difference between the highest and the lowest Amount (in $) in India?
Offer a very short reply. 1.02e+13. 